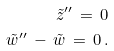<formula> <loc_0><loc_0><loc_500><loc_500>\tilde { z } ^ { \prime \prime } \, = \, 0 \\ \tilde { w } ^ { \prime \prime } \, - \, \tilde { w } \, = \, 0 \, .</formula> 